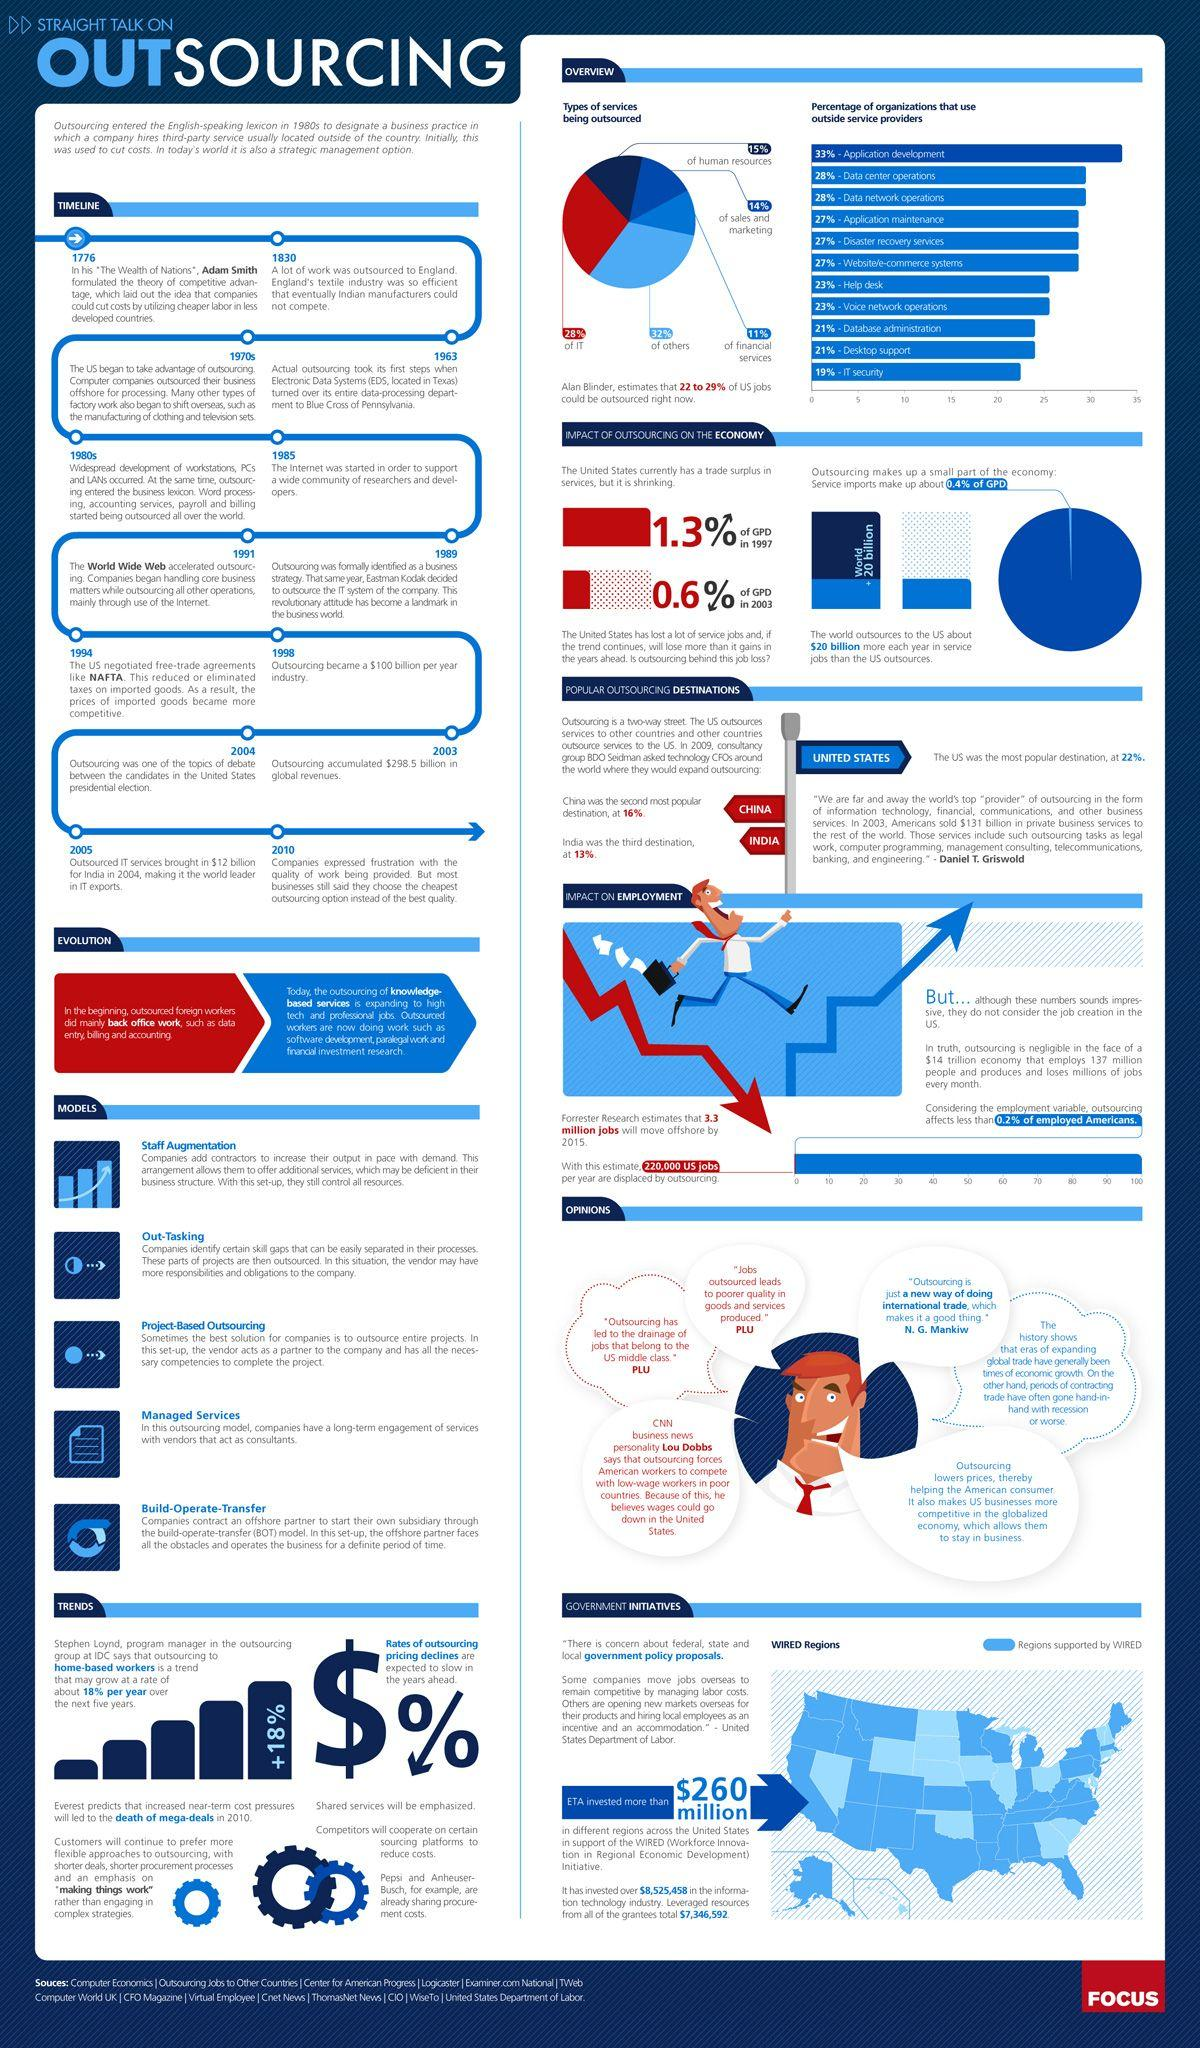Specify some key components in this picture. The United States, China, and India are the countries that hold the first three ranks in outsourcing. It is estimated that approximately five types of services are commonly outsourced. The year 1985 led the way to the genesis of the internet. The difference in percentage between organizations outsourcing application development and IT security is 14%. The first recorded instance of outsourcing occurred in 1963. 